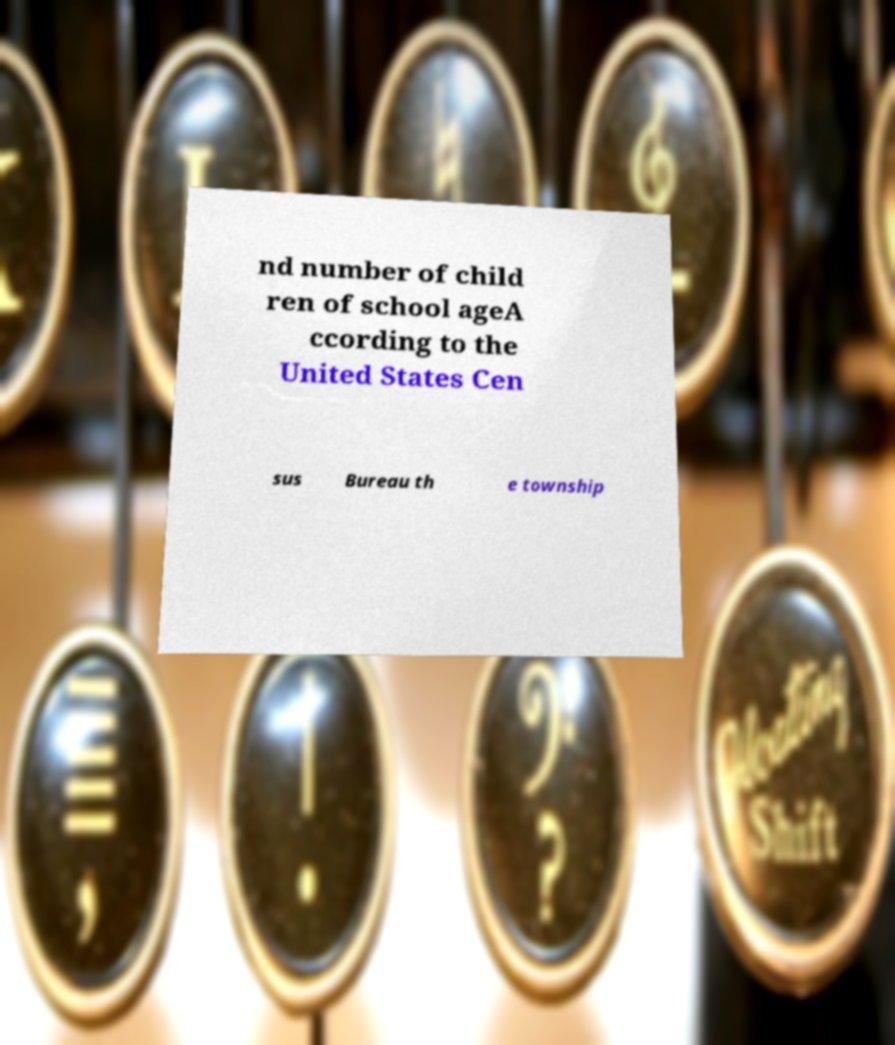Could you extract and type out the text from this image? nd number of child ren of school ageA ccording to the United States Cen sus Bureau th e township 